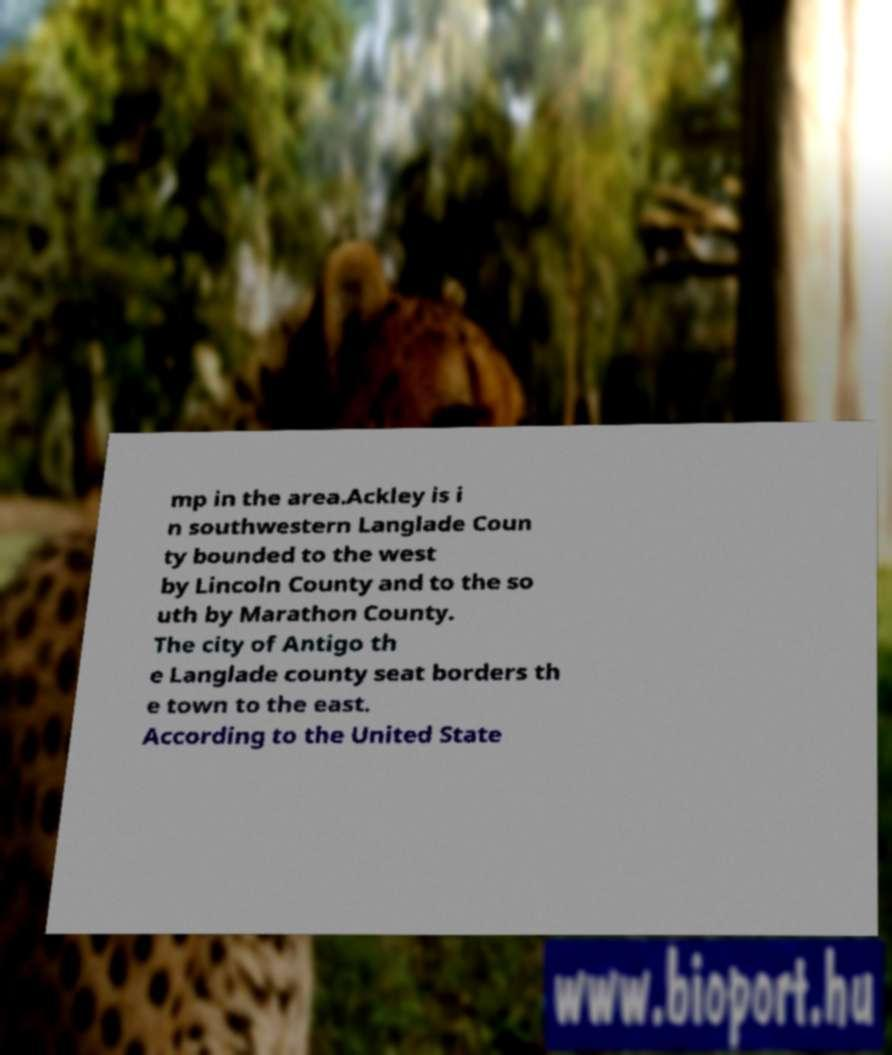Can you read and provide the text displayed in the image?This photo seems to have some interesting text. Can you extract and type it out for me? mp in the area.Ackley is i n southwestern Langlade Coun ty bounded to the west by Lincoln County and to the so uth by Marathon County. The city of Antigo th e Langlade county seat borders th e town to the east. According to the United State 